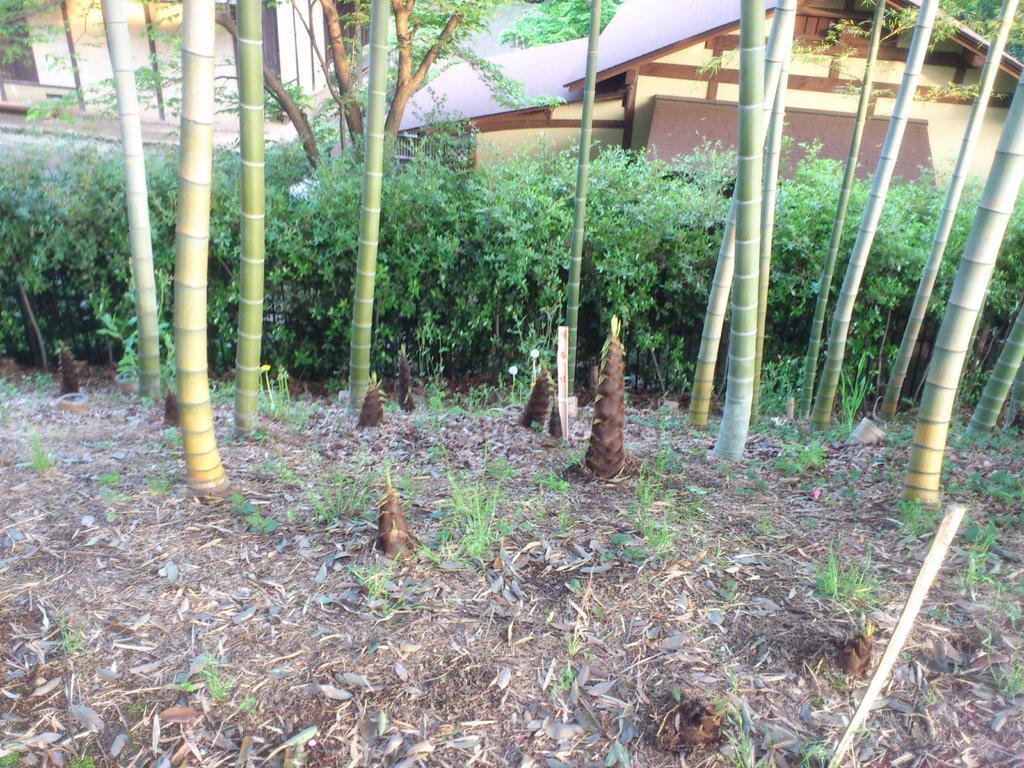In one or two sentences, can you explain what this image depicts? In this image I can see the ground, few leaves on the ground and few trees which are green and brown in color. In the background I can see few buildings which are brown and cream in color and the ground. 